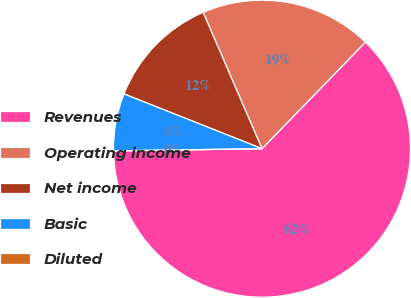Convert chart. <chart><loc_0><loc_0><loc_500><loc_500><pie_chart><fcel>Revenues<fcel>Operating income<fcel>Net income<fcel>Basic<fcel>Diluted<nl><fcel>62.5%<fcel>18.75%<fcel>12.5%<fcel>6.25%<fcel>0.0%<nl></chart> 